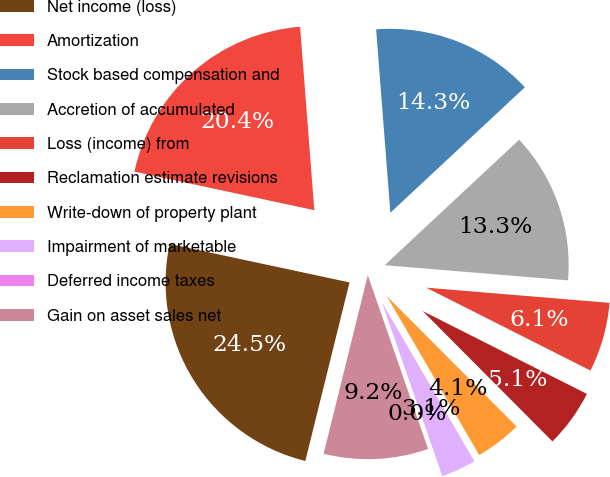Convert chart. <chart><loc_0><loc_0><loc_500><loc_500><pie_chart><fcel>Net income (loss)<fcel>Amortization<fcel>Stock based compensation and<fcel>Accretion of accumulated<fcel>Loss (income) from<fcel>Reclamation estimate revisions<fcel>Write-down of property plant<fcel>Impairment of marketable<fcel>Deferred income taxes<fcel>Gain on asset sales net<nl><fcel>24.49%<fcel>20.41%<fcel>14.28%<fcel>13.26%<fcel>6.12%<fcel>5.1%<fcel>4.08%<fcel>3.06%<fcel>0.0%<fcel>9.18%<nl></chart> 